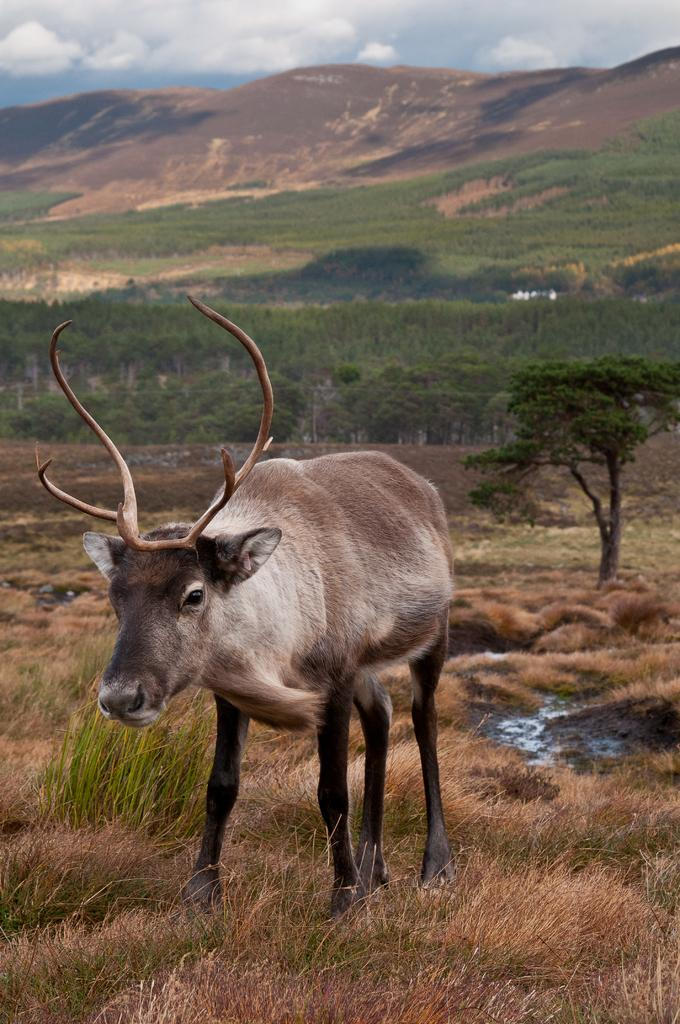What type of animal is in the image? The type of animal cannot be determined from the provided facts. Where is the animal located in the image? The animal is on the grass in the image. What can be seen in the background of the image? There are trees, a hill, and the sky visible in the background of the image. What is the condition of the sky in the image? The sky is visible in the background of the image, and clouds are present. What type of sign is the animal holding in the image? There is no sign present in the image, and the animal is not holding anything. What kind of glue is being used to attach the animal to the grass in the image? The animal is not attached to the grass, and there is no glue present in the image. 